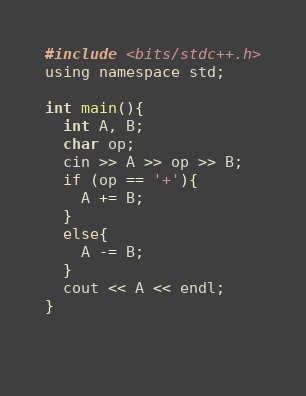Convert code to text. <code><loc_0><loc_0><loc_500><loc_500><_C++_>#include <bits/stdc++.h>
using namespace std;

int main(){
  int A, B;
  char op;
  cin >> A >> op >> B;
  if (op == '+'){
    A += B;
  }
  else{
    A -= B;
  }
  cout << A << endl;
}

  </code> 